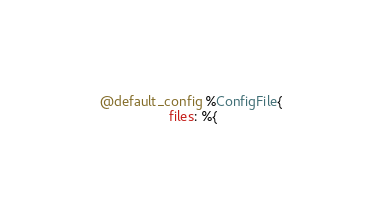Convert code to text. <code><loc_0><loc_0><loc_500><loc_500><_Elixir_>  @default_config %ConfigFile{
                    files: %{</code> 